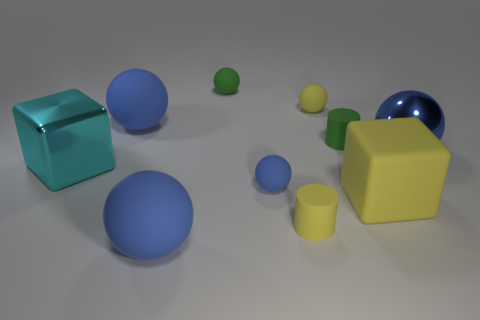Subtract all brown cylinders. How many blue spheres are left? 4 Subtract 1 balls. How many balls are left? 5 Subtract all yellow balls. How many balls are left? 5 Subtract all yellow matte balls. How many balls are left? 5 Subtract all green spheres. Subtract all gray blocks. How many spheres are left? 5 Subtract all cubes. How many objects are left? 8 Add 5 tiny yellow things. How many tiny yellow things are left? 7 Add 4 small brown cubes. How many small brown cubes exist? 4 Subtract 0 brown cylinders. How many objects are left? 10 Subtract all blocks. Subtract all small blue matte balls. How many objects are left? 7 